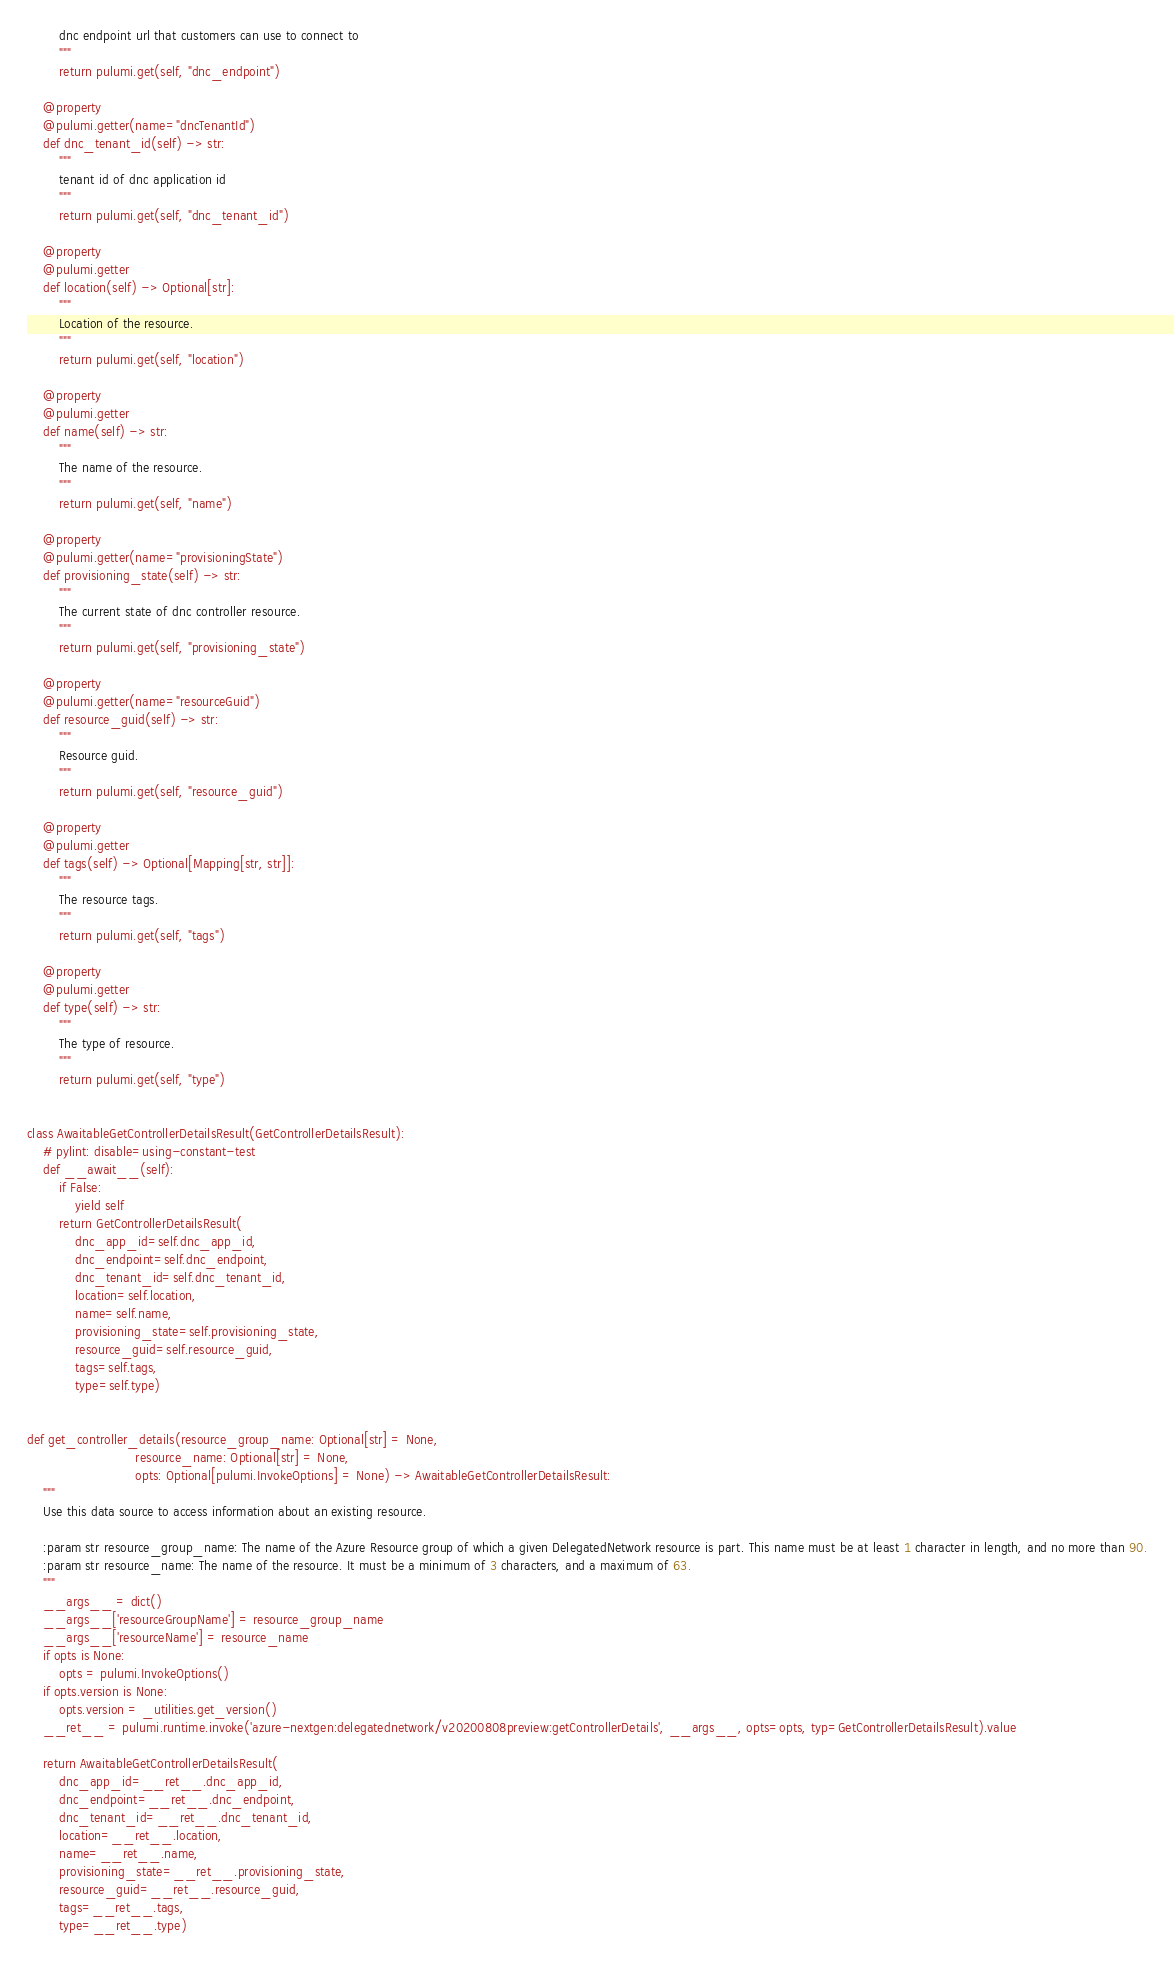Convert code to text. <code><loc_0><loc_0><loc_500><loc_500><_Python_>        dnc endpoint url that customers can use to connect to
        """
        return pulumi.get(self, "dnc_endpoint")

    @property
    @pulumi.getter(name="dncTenantId")
    def dnc_tenant_id(self) -> str:
        """
        tenant id of dnc application id
        """
        return pulumi.get(self, "dnc_tenant_id")

    @property
    @pulumi.getter
    def location(self) -> Optional[str]:
        """
        Location of the resource.
        """
        return pulumi.get(self, "location")

    @property
    @pulumi.getter
    def name(self) -> str:
        """
        The name of the resource.
        """
        return pulumi.get(self, "name")

    @property
    @pulumi.getter(name="provisioningState")
    def provisioning_state(self) -> str:
        """
        The current state of dnc controller resource.
        """
        return pulumi.get(self, "provisioning_state")

    @property
    @pulumi.getter(name="resourceGuid")
    def resource_guid(self) -> str:
        """
        Resource guid.
        """
        return pulumi.get(self, "resource_guid")

    @property
    @pulumi.getter
    def tags(self) -> Optional[Mapping[str, str]]:
        """
        The resource tags.
        """
        return pulumi.get(self, "tags")

    @property
    @pulumi.getter
    def type(self) -> str:
        """
        The type of resource.
        """
        return pulumi.get(self, "type")


class AwaitableGetControllerDetailsResult(GetControllerDetailsResult):
    # pylint: disable=using-constant-test
    def __await__(self):
        if False:
            yield self
        return GetControllerDetailsResult(
            dnc_app_id=self.dnc_app_id,
            dnc_endpoint=self.dnc_endpoint,
            dnc_tenant_id=self.dnc_tenant_id,
            location=self.location,
            name=self.name,
            provisioning_state=self.provisioning_state,
            resource_guid=self.resource_guid,
            tags=self.tags,
            type=self.type)


def get_controller_details(resource_group_name: Optional[str] = None,
                           resource_name: Optional[str] = None,
                           opts: Optional[pulumi.InvokeOptions] = None) -> AwaitableGetControllerDetailsResult:
    """
    Use this data source to access information about an existing resource.

    :param str resource_group_name: The name of the Azure Resource group of which a given DelegatedNetwork resource is part. This name must be at least 1 character in length, and no more than 90.
    :param str resource_name: The name of the resource. It must be a minimum of 3 characters, and a maximum of 63.
    """
    __args__ = dict()
    __args__['resourceGroupName'] = resource_group_name
    __args__['resourceName'] = resource_name
    if opts is None:
        opts = pulumi.InvokeOptions()
    if opts.version is None:
        opts.version = _utilities.get_version()
    __ret__ = pulumi.runtime.invoke('azure-nextgen:delegatednetwork/v20200808preview:getControllerDetails', __args__, opts=opts, typ=GetControllerDetailsResult).value

    return AwaitableGetControllerDetailsResult(
        dnc_app_id=__ret__.dnc_app_id,
        dnc_endpoint=__ret__.dnc_endpoint,
        dnc_tenant_id=__ret__.dnc_tenant_id,
        location=__ret__.location,
        name=__ret__.name,
        provisioning_state=__ret__.provisioning_state,
        resource_guid=__ret__.resource_guid,
        tags=__ret__.tags,
        type=__ret__.type)
</code> 